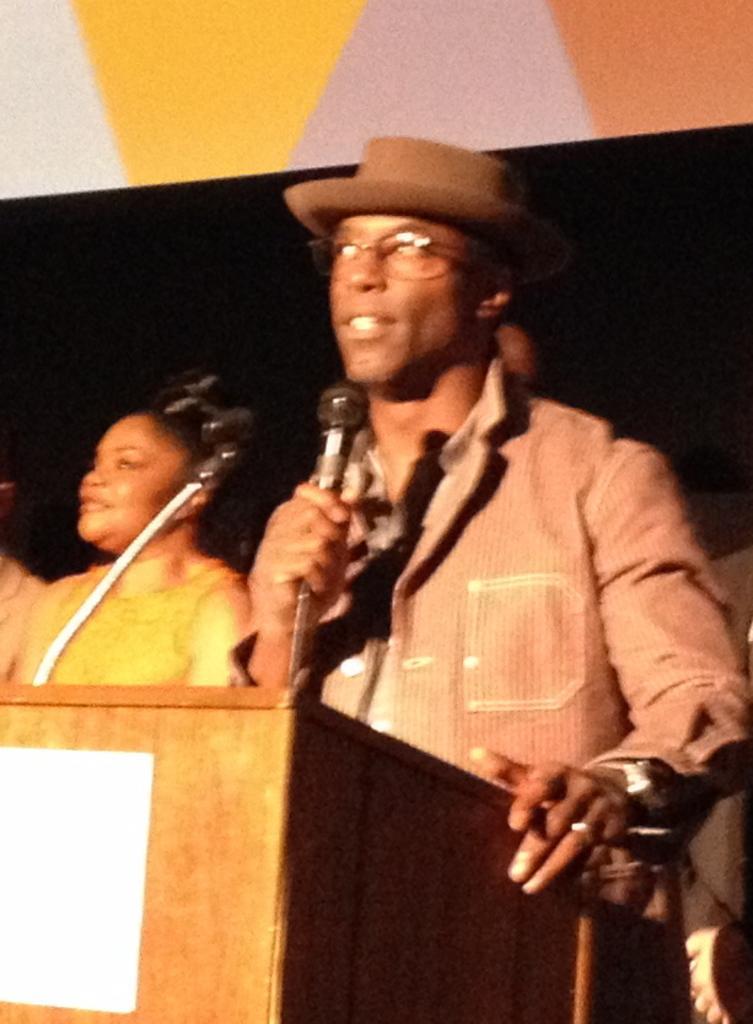In one or two sentences, can you explain what this image depicts? In this image we can see few people. A person is standing near a podium and speaking into a microphone. We can see a person wearing a hat in the image. We can see an object at the top of the image. 